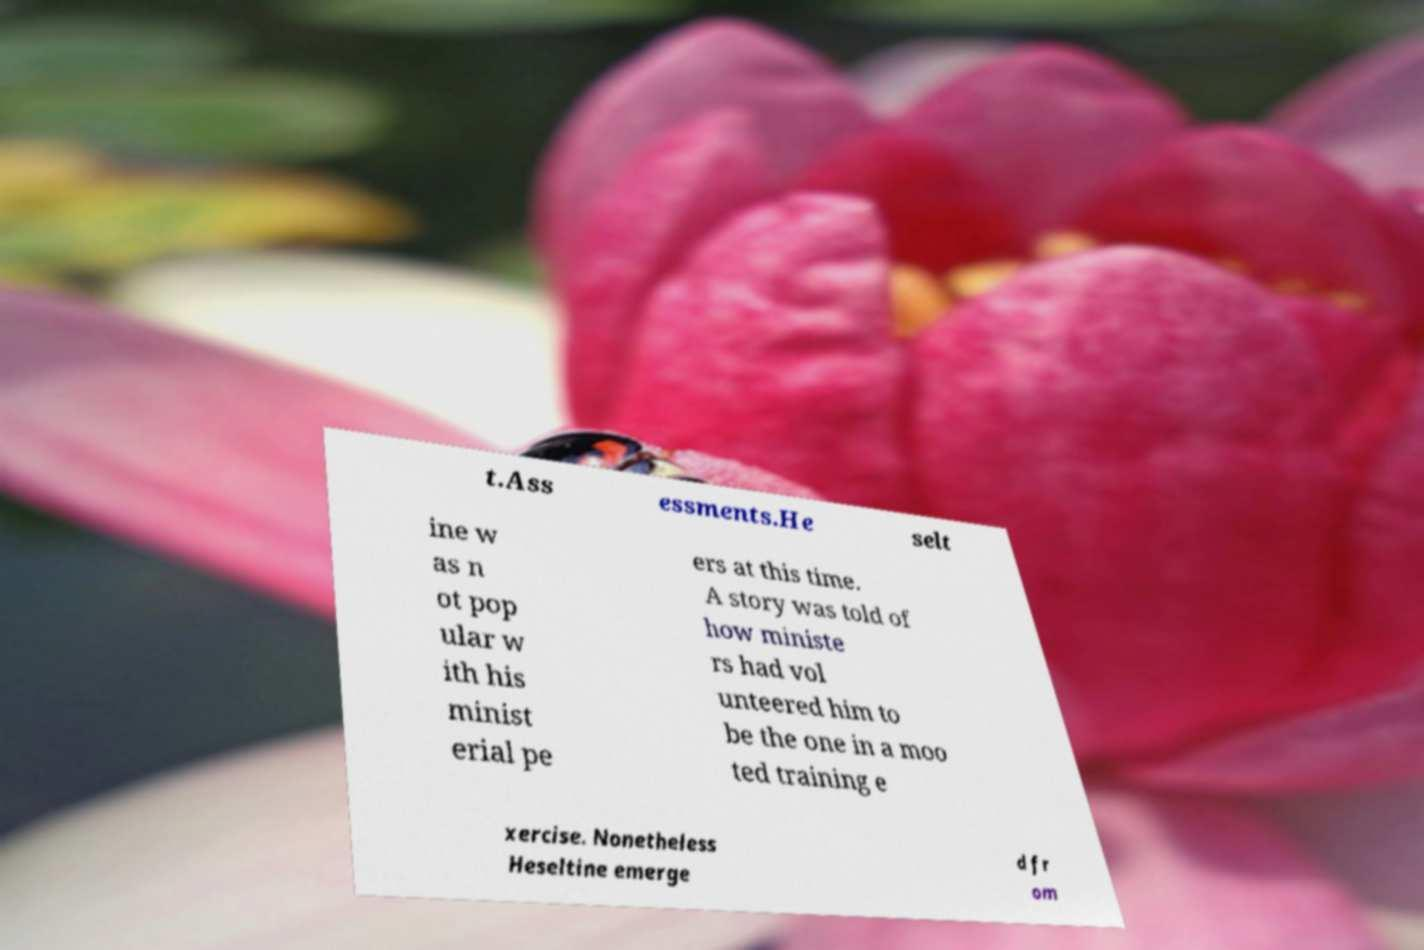Please identify and transcribe the text found in this image. t.Ass essments.He selt ine w as n ot pop ular w ith his minist erial pe ers at this time. A story was told of how ministe rs had vol unteered him to be the one in a moo ted training e xercise. Nonetheless Heseltine emerge d fr om 